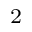Convert formula to latex. <formula><loc_0><loc_0><loc_500><loc_500>_ { 2 }</formula> 